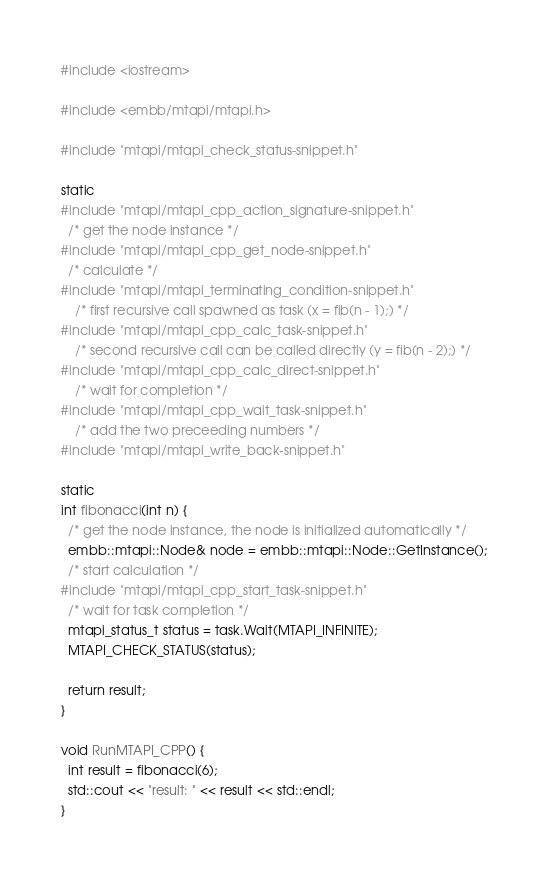<code> <loc_0><loc_0><loc_500><loc_500><_C++_>#include <iostream>

#include <embb/mtapi/mtapi.h>

#include "mtapi/mtapi_check_status-snippet.h"

static
#include "mtapi/mtapi_cpp_action_signature-snippet.h"
  /* get the node instance */
#include "mtapi/mtapi_cpp_get_node-snippet.h"
  /* calculate */
#include "mtapi/mtapi_terminating_condition-snippet.h"
    /* first recursive call spawned as task (x = fib(n - 1);) */
#include "mtapi/mtapi_cpp_calc_task-snippet.h"
    /* second recursive call can be called directly (y = fib(n - 2);) */
#include "mtapi/mtapi_cpp_calc_direct-snippet.h"
    /* wait for completion */
#include "mtapi/mtapi_cpp_wait_task-snippet.h"
    /* add the two preceeding numbers */
#include "mtapi/mtapi_write_back-snippet.h"

static
int fibonacci(int n) {
  /* get the node instance, the node is initialized automatically */
  embb::mtapi::Node& node = embb::mtapi::Node::GetInstance();
  /* start calculation */
#include "mtapi/mtapi_cpp_start_task-snippet.h"
  /* wait for task completion */
  mtapi_status_t status = task.Wait(MTAPI_INFINITE);
  MTAPI_CHECK_STATUS(status);

  return result;
}

void RunMTAPI_CPP() {
  int result = fibonacci(6);
  std::cout << "result: " << result << std::endl;
}
</code> 